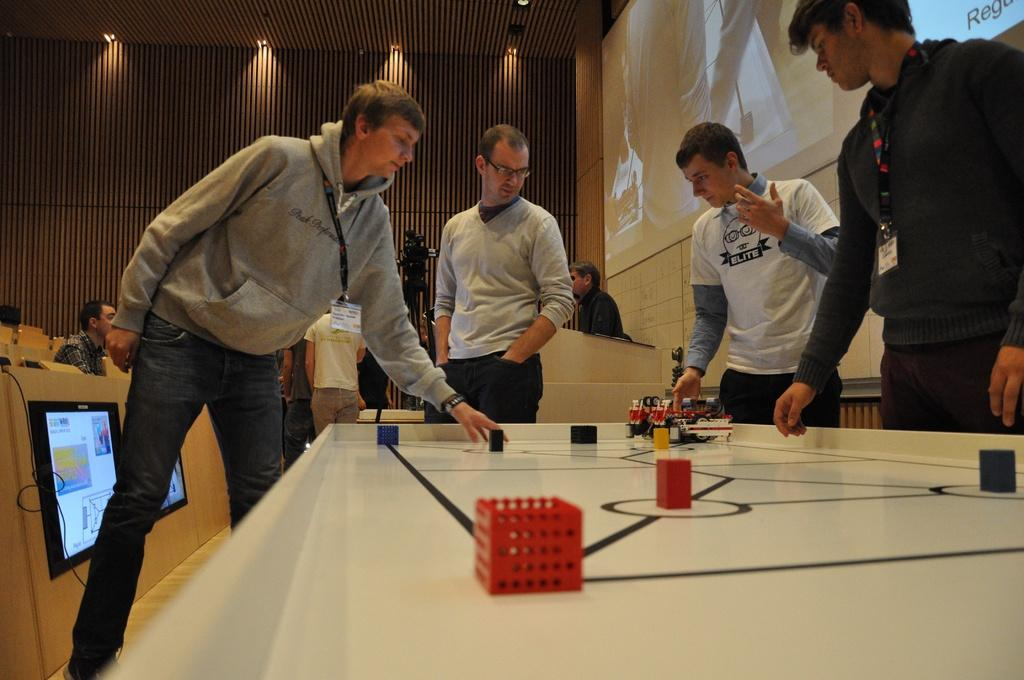How many people are in the image? There is a group of men in the image. What are the men doing in the image? The men are standing in front of a table. What can be seen on the table in the image? There are objects on the table. What type of cub is visible on the table in the image? There is no cub present on the table in the image. 